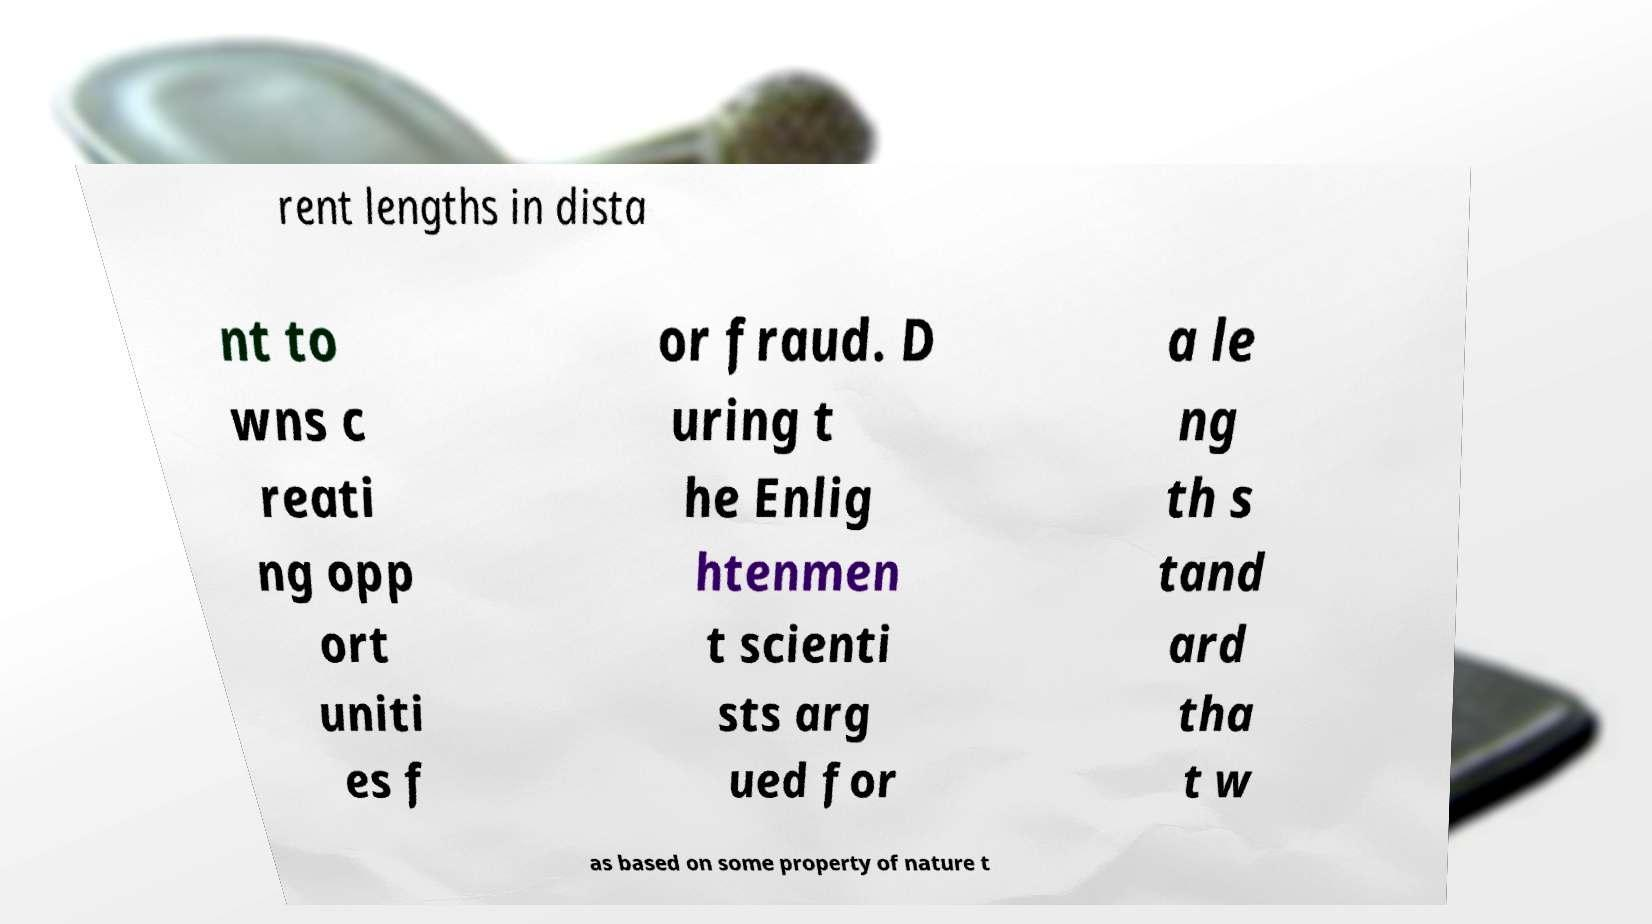Could you extract and type out the text from this image? rent lengths in dista nt to wns c reati ng opp ort uniti es f or fraud. D uring t he Enlig htenmen t scienti sts arg ued for a le ng th s tand ard tha t w as based on some property of nature t 